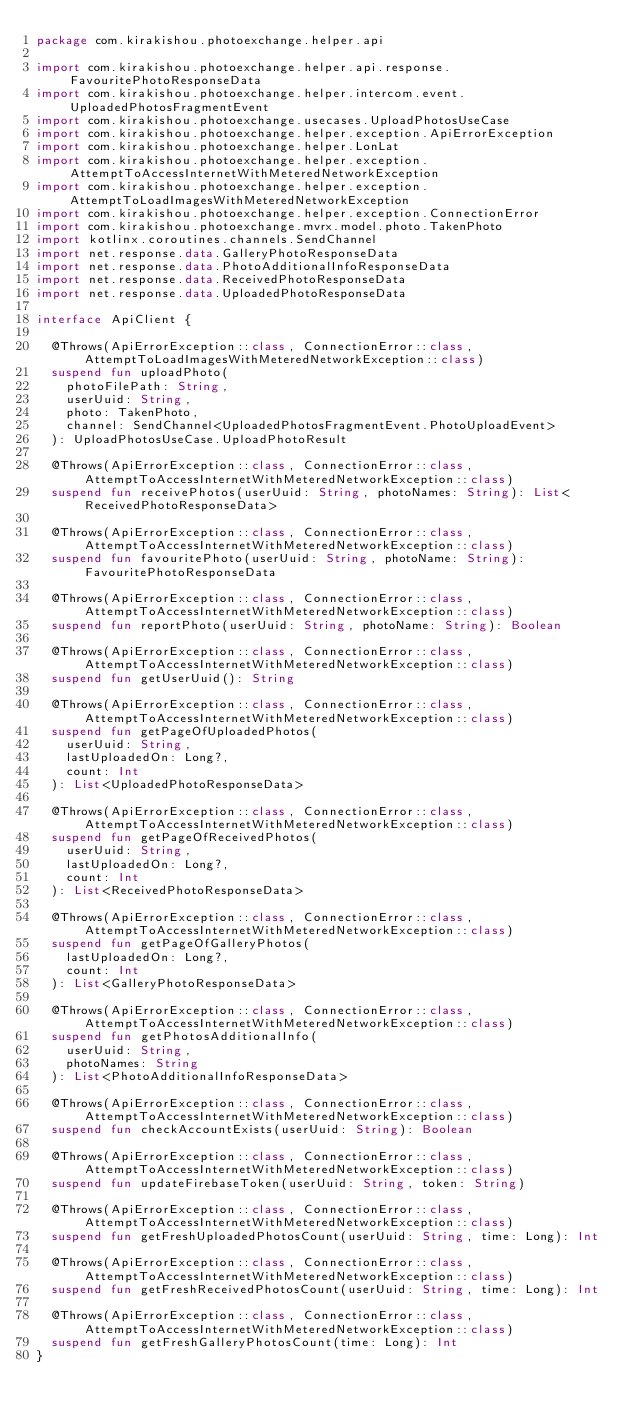<code> <loc_0><loc_0><loc_500><loc_500><_Kotlin_>package com.kirakishou.photoexchange.helper.api

import com.kirakishou.photoexchange.helper.api.response.FavouritePhotoResponseData
import com.kirakishou.photoexchange.helper.intercom.event.UploadedPhotosFragmentEvent
import com.kirakishou.photoexchange.usecases.UploadPhotosUseCase
import com.kirakishou.photoexchange.helper.exception.ApiErrorException
import com.kirakishou.photoexchange.helper.LonLat
import com.kirakishou.photoexchange.helper.exception.AttemptToAccessInternetWithMeteredNetworkException
import com.kirakishou.photoexchange.helper.exception.AttemptToLoadImagesWithMeteredNetworkException
import com.kirakishou.photoexchange.helper.exception.ConnectionError
import com.kirakishou.photoexchange.mvrx.model.photo.TakenPhoto
import kotlinx.coroutines.channels.SendChannel
import net.response.data.GalleryPhotoResponseData
import net.response.data.PhotoAdditionalInfoResponseData
import net.response.data.ReceivedPhotoResponseData
import net.response.data.UploadedPhotoResponseData

interface ApiClient {

  @Throws(ApiErrorException::class, ConnectionError::class, AttemptToLoadImagesWithMeteredNetworkException::class)
  suspend fun uploadPhoto(
    photoFilePath: String,
    userUuid: String,
    photo: TakenPhoto,
    channel: SendChannel<UploadedPhotosFragmentEvent.PhotoUploadEvent>
  ): UploadPhotosUseCase.UploadPhotoResult

  @Throws(ApiErrorException::class, ConnectionError::class, AttemptToAccessInternetWithMeteredNetworkException::class)
  suspend fun receivePhotos(userUuid: String, photoNames: String): List<ReceivedPhotoResponseData>

  @Throws(ApiErrorException::class, ConnectionError::class, AttemptToAccessInternetWithMeteredNetworkException::class)
  suspend fun favouritePhoto(userUuid: String, photoName: String): FavouritePhotoResponseData

  @Throws(ApiErrorException::class, ConnectionError::class, AttemptToAccessInternetWithMeteredNetworkException::class)
  suspend fun reportPhoto(userUuid: String, photoName: String): Boolean

  @Throws(ApiErrorException::class, ConnectionError::class, AttemptToAccessInternetWithMeteredNetworkException::class)
  suspend fun getUserUuid(): String

  @Throws(ApiErrorException::class, ConnectionError::class, AttemptToAccessInternetWithMeteredNetworkException::class)
  suspend fun getPageOfUploadedPhotos(
    userUuid: String,
    lastUploadedOn: Long?,
    count: Int
  ): List<UploadedPhotoResponseData>

  @Throws(ApiErrorException::class, ConnectionError::class, AttemptToAccessInternetWithMeteredNetworkException::class)
  suspend fun getPageOfReceivedPhotos(
    userUuid: String,
    lastUploadedOn: Long?,
    count: Int
  ): List<ReceivedPhotoResponseData>

  @Throws(ApiErrorException::class, ConnectionError::class, AttemptToAccessInternetWithMeteredNetworkException::class)
  suspend fun getPageOfGalleryPhotos(
    lastUploadedOn: Long?,
    count: Int
  ): List<GalleryPhotoResponseData>

  @Throws(ApiErrorException::class, ConnectionError::class, AttemptToAccessInternetWithMeteredNetworkException::class)
  suspend fun getPhotosAdditionalInfo(
    userUuid: String,
    photoNames: String
  ): List<PhotoAdditionalInfoResponseData>

  @Throws(ApiErrorException::class, ConnectionError::class, AttemptToAccessInternetWithMeteredNetworkException::class)
  suspend fun checkAccountExists(userUuid: String): Boolean

  @Throws(ApiErrorException::class, ConnectionError::class, AttemptToAccessInternetWithMeteredNetworkException::class)
  suspend fun updateFirebaseToken(userUuid: String, token: String)

  @Throws(ApiErrorException::class, ConnectionError::class, AttemptToAccessInternetWithMeteredNetworkException::class)
  suspend fun getFreshUploadedPhotosCount(userUuid: String, time: Long): Int

  @Throws(ApiErrorException::class, ConnectionError::class, AttemptToAccessInternetWithMeteredNetworkException::class)
  suspend fun getFreshReceivedPhotosCount(userUuid: String, time: Long): Int

  @Throws(ApiErrorException::class, ConnectionError::class, AttemptToAccessInternetWithMeteredNetworkException::class)
  suspend fun getFreshGalleryPhotosCount(time: Long): Int
}</code> 